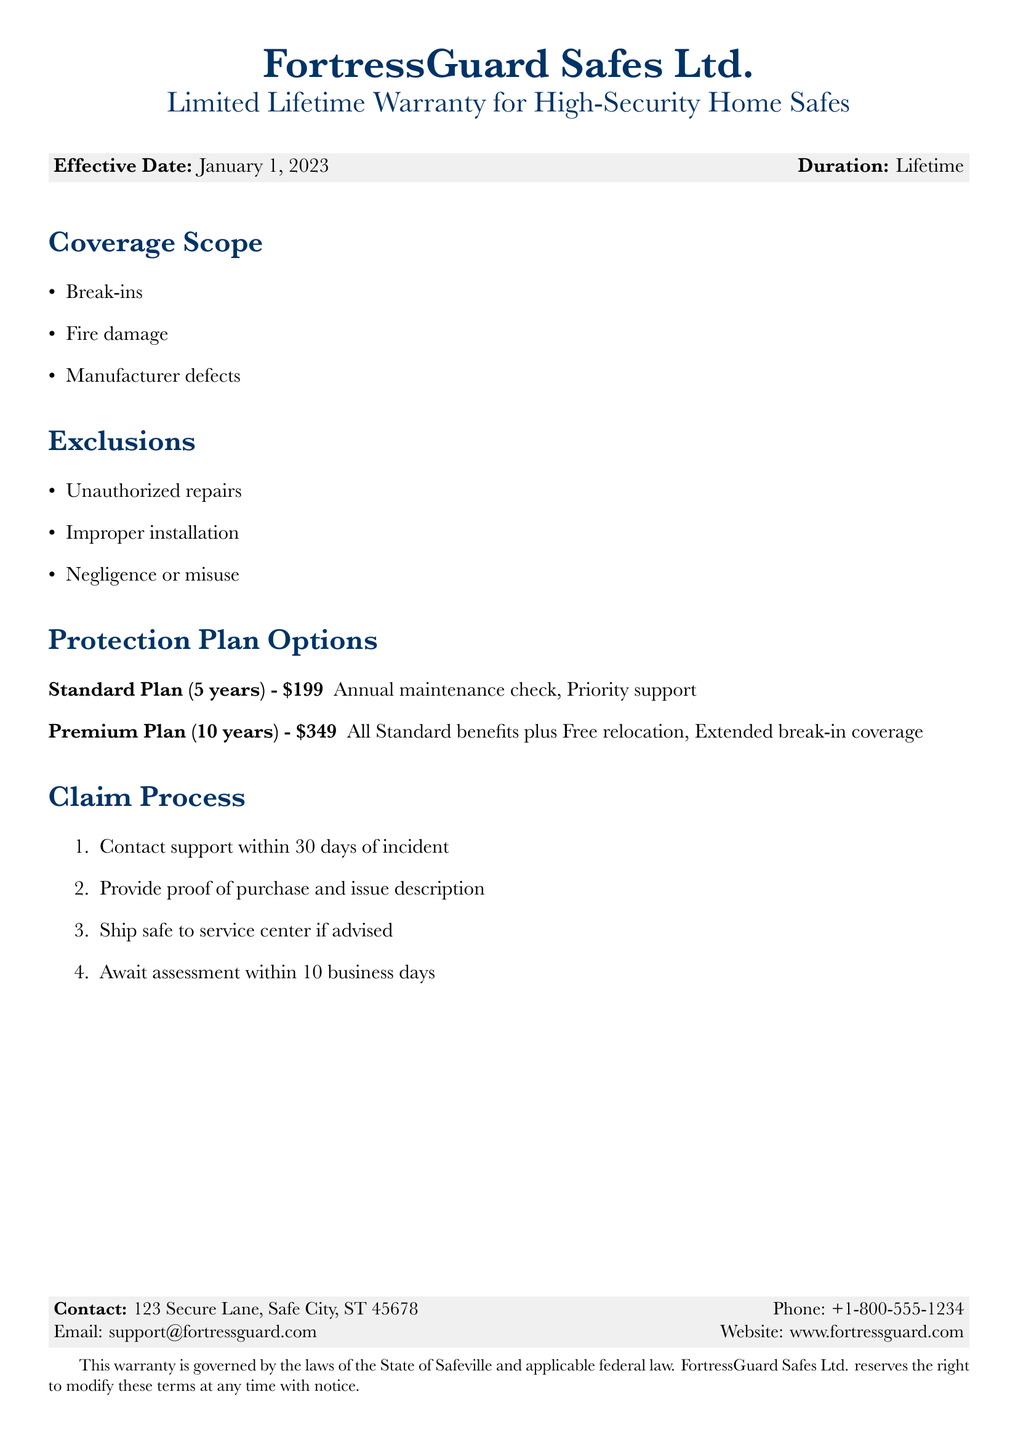What is the effective date of the warranty? The effective date of the warranty is clearly stated in the document.
Answer: January 1, 2023 What is the duration of the warranty? The duration of the warranty is mentioned right next to the effective date.
Answer: Lifetime What are the exclusions mentioned in the warranty? The document lists specific exclusions in the warranty section.
Answer: Unauthorized repairs, Improper installation, Negligence or misuse What is the price of the Premium Plan? The price for the Premium Plan is provided under the Protection Plan Options section.
Answer: $349 How long do you have to contact support after an incident? The claim process section specifies the time frame to contact support.
Answer: 30 days What is included in the Standard Plan? The benefits of the Standard Plan are outlined in the Protection Plan Options section.
Answer: Annual maintenance check, Priority support What is the assessment time frame after shipping the safe? The claim process specifies how long it takes to await an assessment.
Answer: 10 business days What are the manufacturer defects covered by the warranty? Manufacturer defects are one of the coverage aspects listed in the Coverage Scope.
Answer: Manufacturer defects Which state governs this warranty? The document mentions the governing laws relevant to the warranty terms.
Answer: Safeville 